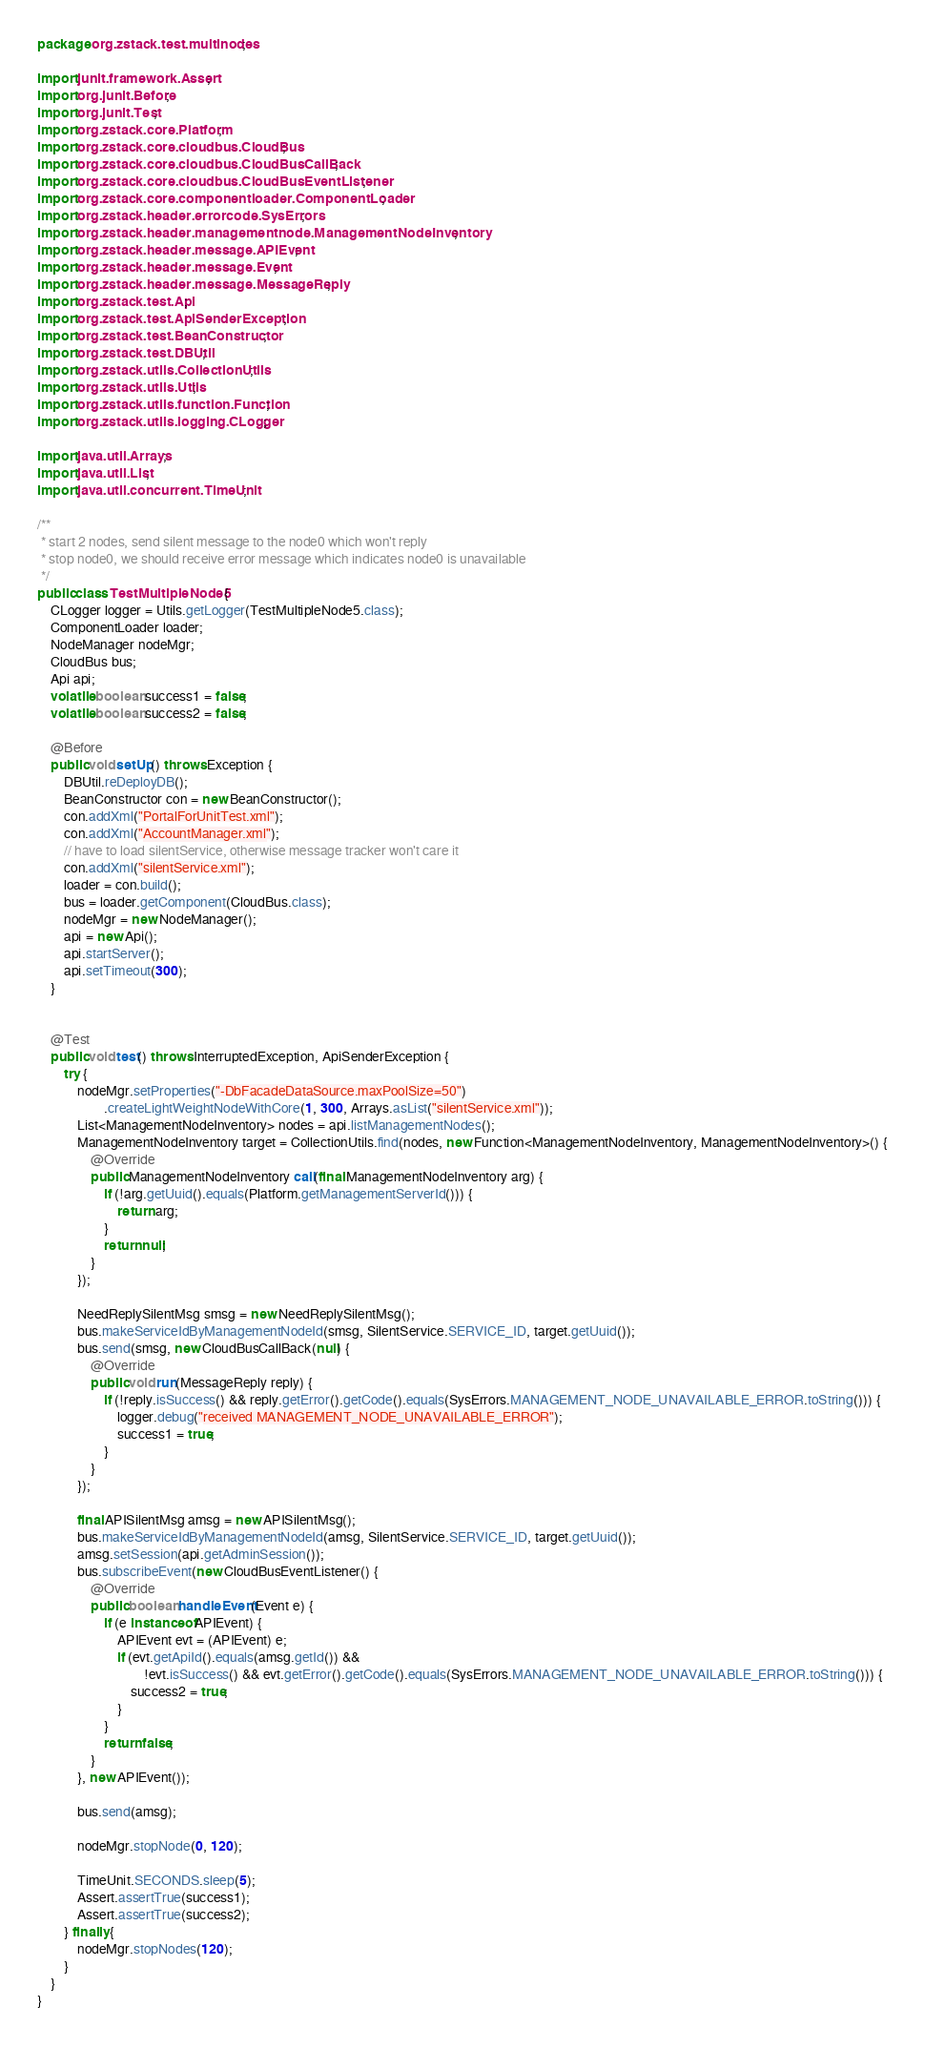<code> <loc_0><loc_0><loc_500><loc_500><_Java_>package org.zstack.test.multinodes;

import junit.framework.Assert;
import org.junit.Before;
import org.junit.Test;
import org.zstack.core.Platform;
import org.zstack.core.cloudbus.CloudBus;
import org.zstack.core.cloudbus.CloudBusCallBack;
import org.zstack.core.cloudbus.CloudBusEventListener;
import org.zstack.core.componentloader.ComponentLoader;
import org.zstack.header.errorcode.SysErrors;
import org.zstack.header.managementnode.ManagementNodeInventory;
import org.zstack.header.message.APIEvent;
import org.zstack.header.message.Event;
import org.zstack.header.message.MessageReply;
import org.zstack.test.Api;
import org.zstack.test.ApiSenderException;
import org.zstack.test.BeanConstructor;
import org.zstack.test.DBUtil;
import org.zstack.utils.CollectionUtils;
import org.zstack.utils.Utils;
import org.zstack.utils.function.Function;
import org.zstack.utils.logging.CLogger;

import java.util.Arrays;
import java.util.List;
import java.util.concurrent.TimeUnit;

/**
 * start 2 nodes, send silent message to the node0 which won't reply
 * stop node0, we should receive error message which indicates node0 is unavailable
 */
public class TestMultipleNode5 {
    CLogger logger = Utils.getLogger(TestMultipleNode5.class);
    ComponentLoader loader;
    NodeManager nodeMgr;
    CloudBus bus;
    Api api;
    volatile boolean success1 = false;
    volatile boolean success2 = false;

    @Before
    public void setUp() throws Exception {
        DBUtil.reDeployDB();
        BeanConstructor con = new BeanConstructor();
        con.addXml("PortalForUnitTest.xml");
        con.addXml("AccountManager.xml");
        // have to load silentService, otherwise message tracker won't care it
        con.addXml("silentService.xml");
        loader = con.build();
        bus = loader.getComponent(CloudBus.class);
        nodeMgr = new NodeManager();
        api = new Api();
        api.startServer();
        api.setTimeout(300);
    }


    @Test
    public void test() throws InterruptedException, ApiSenderException {
        try {
            nodeMgr.setProperties("-DbFacadeDataSource.maxPoolSize=50")
                    .createLightWeightNodeWithCore(1, 300, Arrays.asList("silentService.xml"));
            List<ManagementNodeInventory> nodes = api.listManagementNodes();
            ManagementNodeInventory target = CollectionUtils.find(nodes, new Function<ManagementNodeInventory, ManagementNodeInventory>() {
                @Override
                public ManagementNodeInventory call(final ManagementNodeInventory arg) {
                    if (!arg.getUuid().equals(Platform.getManagementServerId())) {
                        return arg;
                    }
                    return null;
                }
            });

            NeedReplySilentMsg smsg = new NeedReplySilentMsg();
            bus.makeServiceIdByManagementNodeId(smsg, SilentService.SERVICE_ID, target.getUuid());
            bus.send(smsg, new CloudBusCallBack(null) {
                @Override
                public void run(MessageReply reply) {
                    if (!reply.isSuccess() && reply.getError().getCode().equals(SysErrors.MANAGEMENT_NODE_UNAVAILABLE_ERROR.toString())) {
                        logger.debug("received MANAGEMENT_NODE_UNAVAILABLE_ERROR");
                        success1 = true;
                    }
                }
            });

            final APISilentMsg amsg = new APISilentMsg();
            bus.makeServiceIdByManagementNodeId(amsg, SilentService.SERVICE_ID, target.getUuid());
            amsg.setSession(api.getAdminSession());
            bus.subscribeEvent(new CloudBusEventListener() {
                @Override
                public boolean handleEvent(Event e) {
                    if (e instanceof APIEvent) {
                        APIEvent evt = (APIEvent) e;
                        if (evt.getApiId().equals(amsg.getId()) &&
                                !evt.isSuccess() && evt.getError().getCode().equals(SysErrors.MANAGEMENT_NODE_UNAVAILABLE_ERROR.toString())) {
                            success2 = true;
                        }
                    }
                    return false;
                }
            }, new APIEvent());

            bus.send(amsg);

            nodeMgr.stopNode(0, 120);

            TimeUnit.SECONDS.sleep(5);
            Assert.assertTrue(success1);
            Assert.assertTrue(success2);
        } finally {
            nodeMgr.stopNodes(120);
        }
    }
}
</code> 